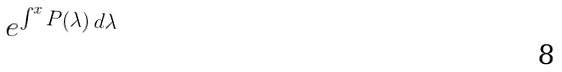Convert formula to latex. <formula><loc_0><loc_0><loc_500><loc_500>e ^ { \int ^ { x } P ( \lambda ) \, d \lambda }</formula> 